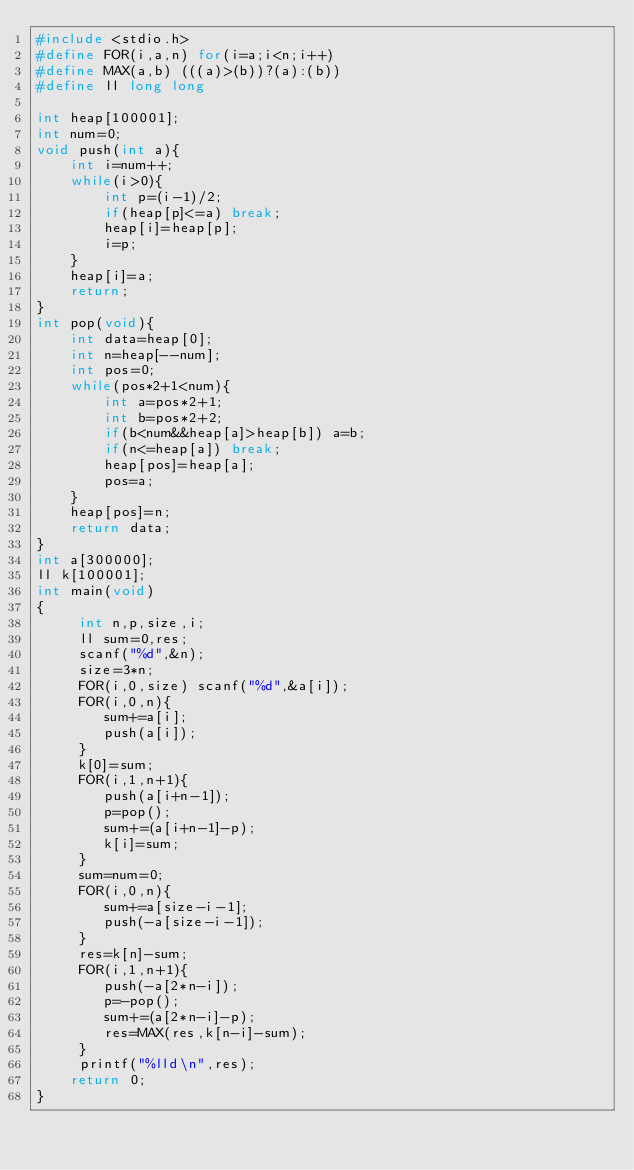<code> <loc_0><loc_0><loc_500><loc_500><_C_>#include <stdio.h>
#define FOR(i,a,n) for(i=a;i<n;i++)
#define MAX(a,b) (((a)>(b))?(a):(b))
#define ll long long

int heap[100001];
int num=0;
void push(int a){
 	int i=num++;
 	while(i>0){
 		int p=(i-1)/2;
 		if(heap[p]<=a) break;
 		heap[i]=heap[p];
 		i=p;
 	}
 	heap[i]=a;
 	return;
}
int pop(void){
 	int data=heap[0];
 	int n=heap[--num];
 	int pos=0;
 	while(pos*2+1<num){
 		int a=pos*2+1;
 		int b=pos*2+2;
 		if(b<num&&heap[a]>heap[b]) a=b;
 		if(n<=heap[a]) break;
 		heap[pos]=heap[a];
 		pos=a;
 	}
 	heap[pos]=n;
 	return data;
}
int a[300000];
ll k[100001];
int main(void)
{
     int n,p,size,i;
     ll sum=0,res;
     scanf("%d",&n);
     size=3*n;
     FOR(i,0,size) scanf("%d",&a[i]);
     FOR(i,0,n){
     	sum+=a[i];
     	push(a[i]);
     }
     k[0]=sum;
     FOR(i,1,n+1){
     	push(a[i+n-1]);
     	p=pop();
     	sum+=(a[i+n-1]-p);
     	k[i]=sum;
     }
     sum=num=0;
     FOR(i,0,n){
     	sum+=a[size-i-1];
     	push(-a[size-i-1]);
     }
     res=k[n]-sum;
     FOR(i,1,n+1){
     	push(-a[2*n-i]);
     	p=-pop();
     	sum+=(a[2*n-i]-p);
     	res=MAX(res,k[n-i]-sum);
     }
     printf("%lld\n",res);
 	return 0;
}
</code> 